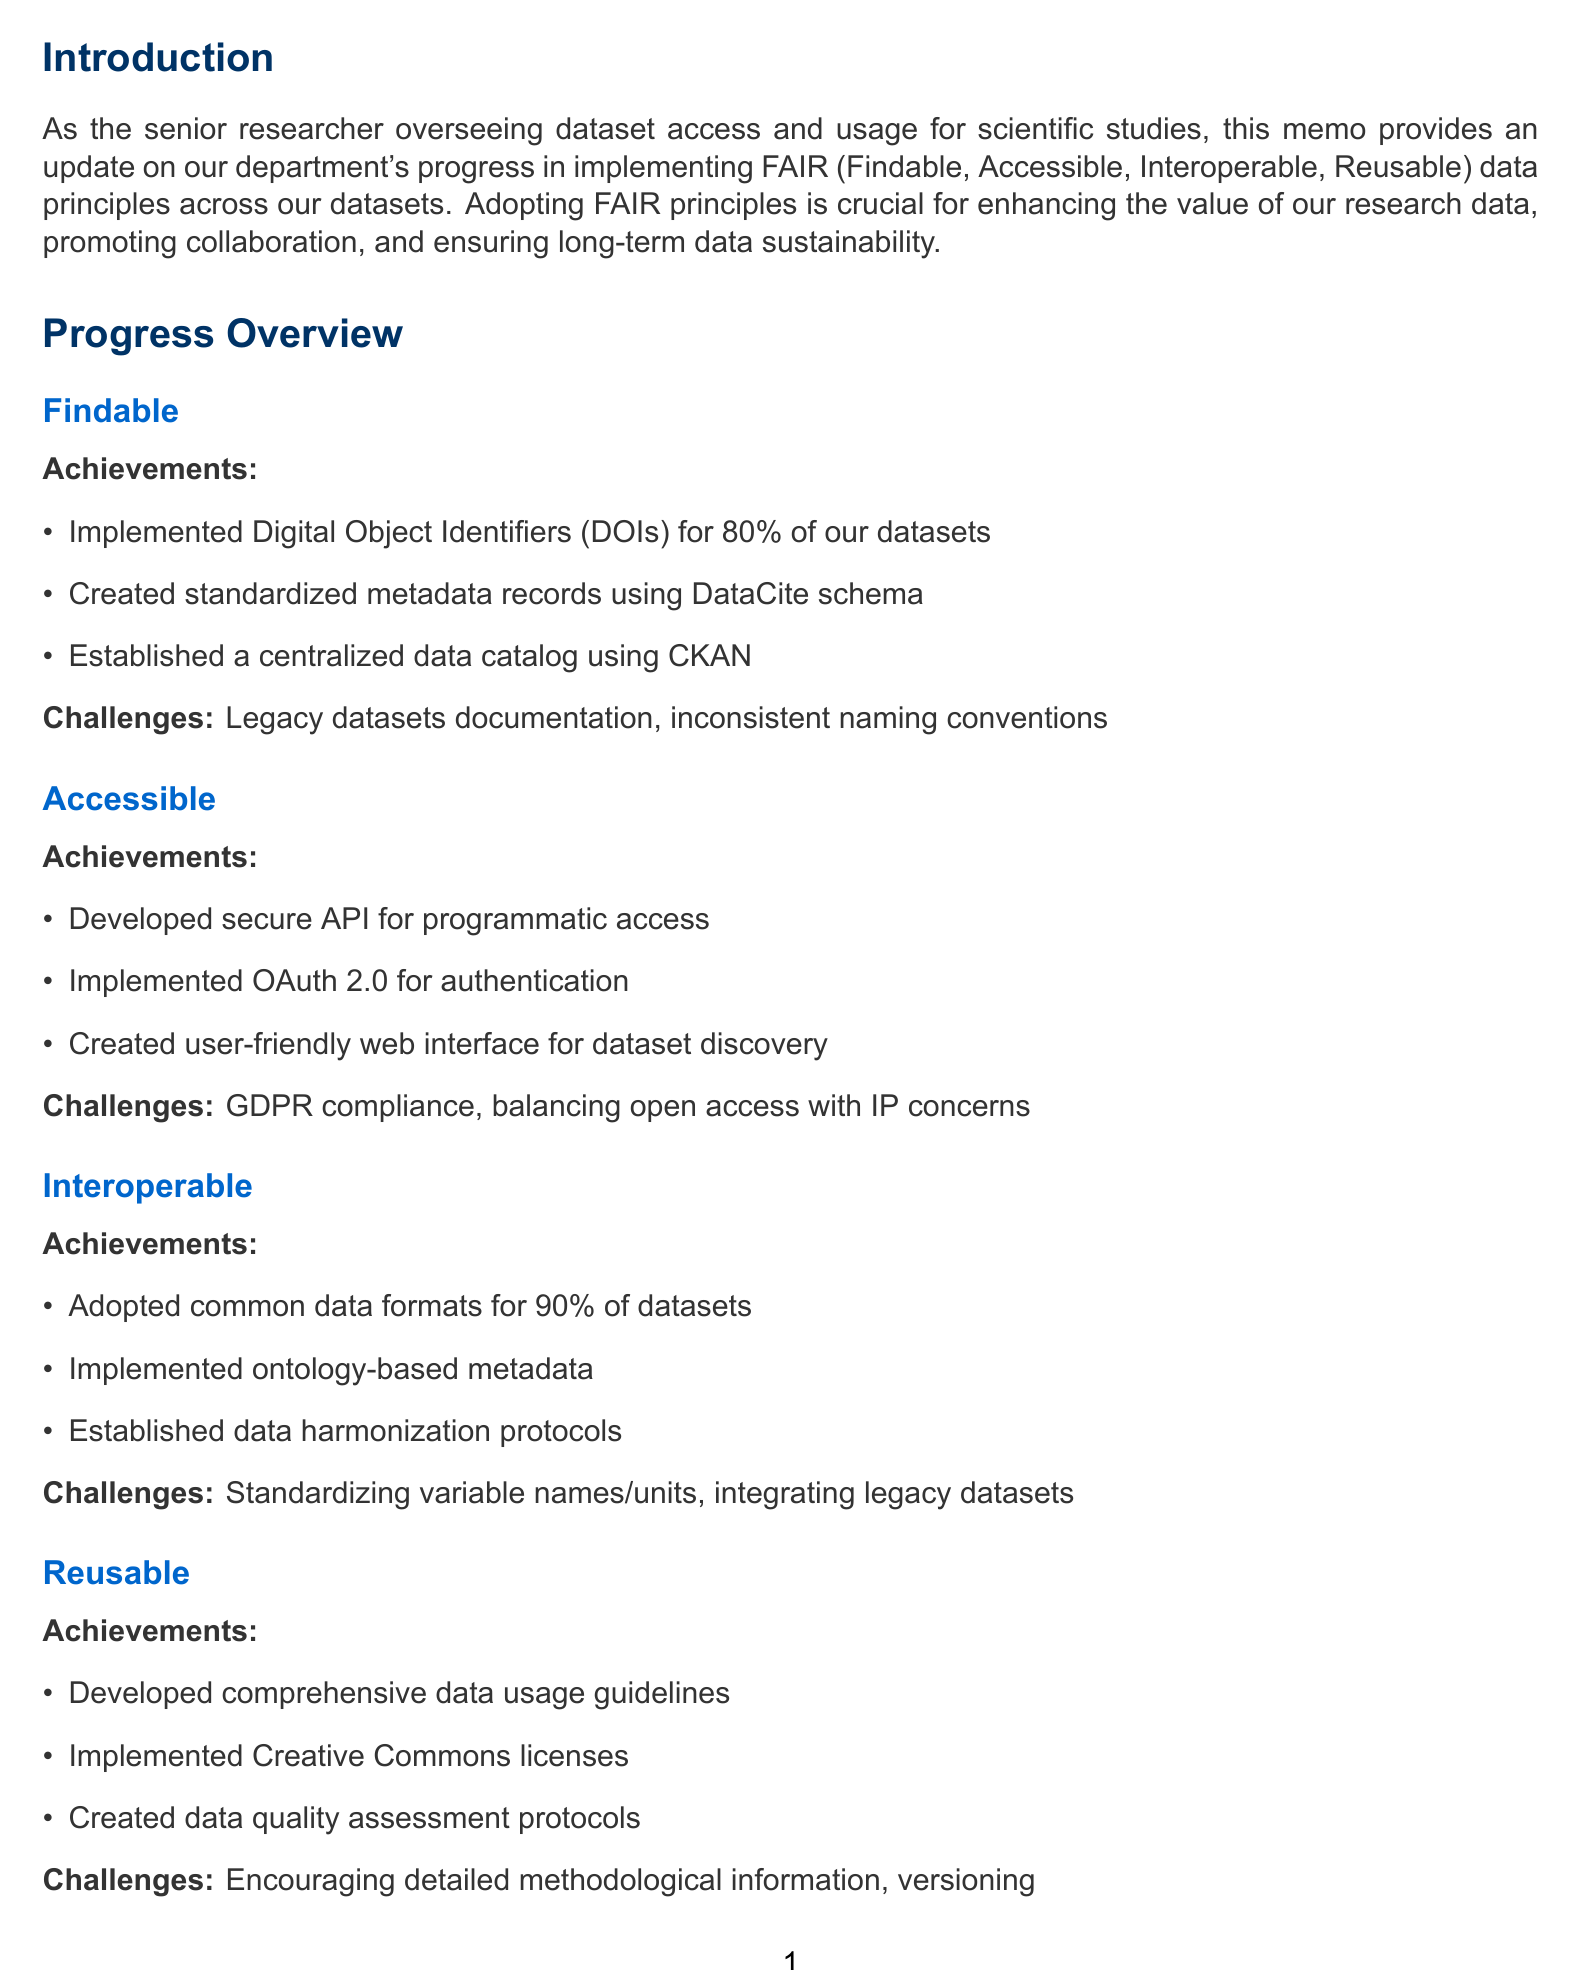What percentage of datasets have DOIs implemented? The document states that 80% of datasets have implemented DOIs.
Answer: 80% What is the primary purpose of the centralized data catalog? The centralized data catalog was established using CKAN to enhance dataset discoverability and accessibility.
Answer: Enhance discoverability What challenge is associated with ensuring compliance for sensitive datasets? The challenge mentioned is ensuring compliance with data protection regulations like GDPR.
Answer: GDPR compliance Which common data formats have been adopted for datasets? The document lists CSV, JSON, and NetCDF as common data formats adopted for 90% of datasets.
Answer: CSV, JSON, NetCDF What is the main goal of the future plans outlined in the memo? The future plans aim to implement machine-actionable Data Management Plans using the RDA DMP Common Standard.
Answer: Machine-actionable Data Management Plans What initiative involves harmonizing international climate datasets? The case study mentions the Global Climate Data Integration Project has successfully harmonized climate datasets.
Answer: Global Climate Data Integration Project What training program is proposed in the future plans? The proposed program in the future plans is a FAIR data stewardship training program.
Answer: FAIR data stewardship training program What type of licenses have been implemented for publicly accessible datasets? The memo states that Creative Commons licenses have been implemented for publicly accessible datasets.
Answer: Creative Commons licenses What significant achievement has been made regarding user authentication? The document notes that OAuth 2.0 has been implemented for user authentication and authorization.
Answer: OAuth 2.0 